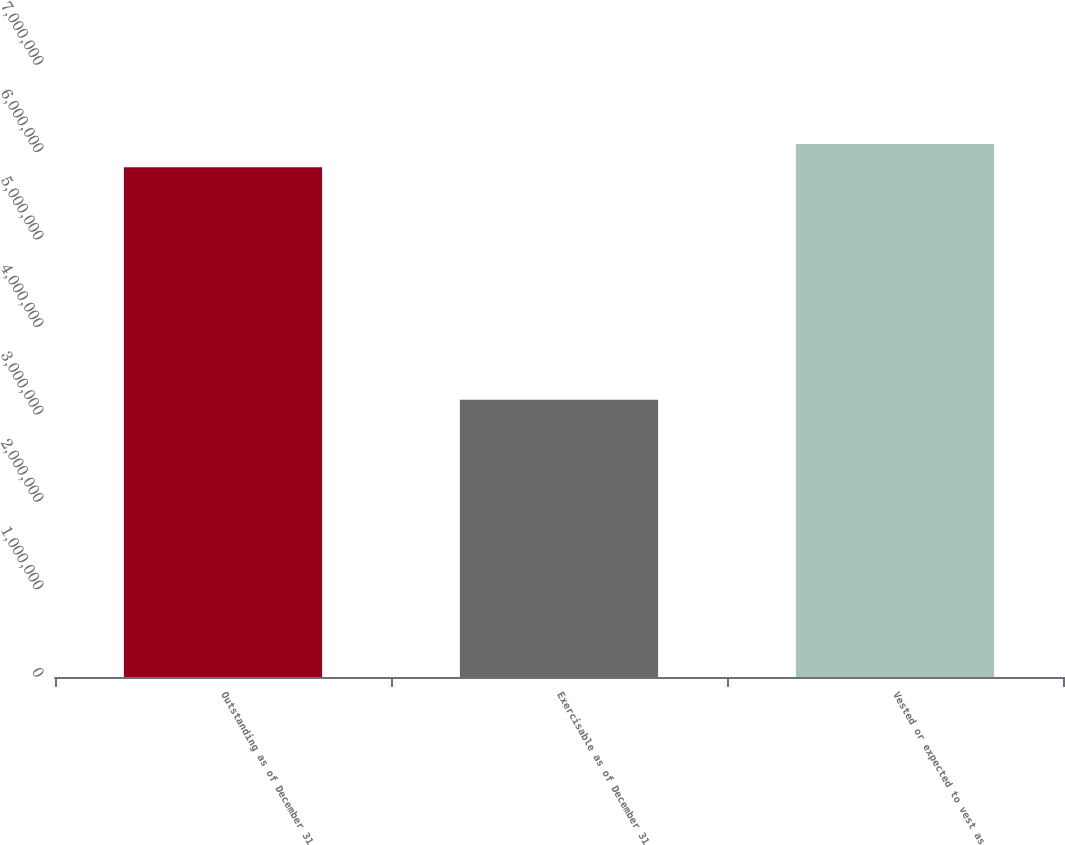<chart> <loc_0><loc_0><loc_500><loc_500><bar_chart><fcel>Outstanding as of December 31<fcel>Exercisable as of December 31<fcel>Vested or expected to vest as<nl><fcel>5.82994e+06<fcel>3.1705e+06<fcel>6.09589e+06<nl></chart> 